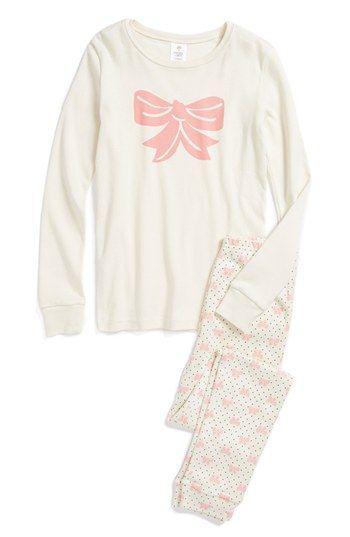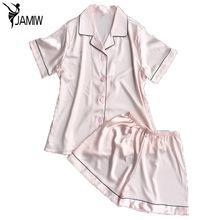The first image is the image on the left, the second image is the image on the right. Considering the images on both sides, is "The right image has a pair of unfolded shorts." valid? Answer yes or no. Yes. 